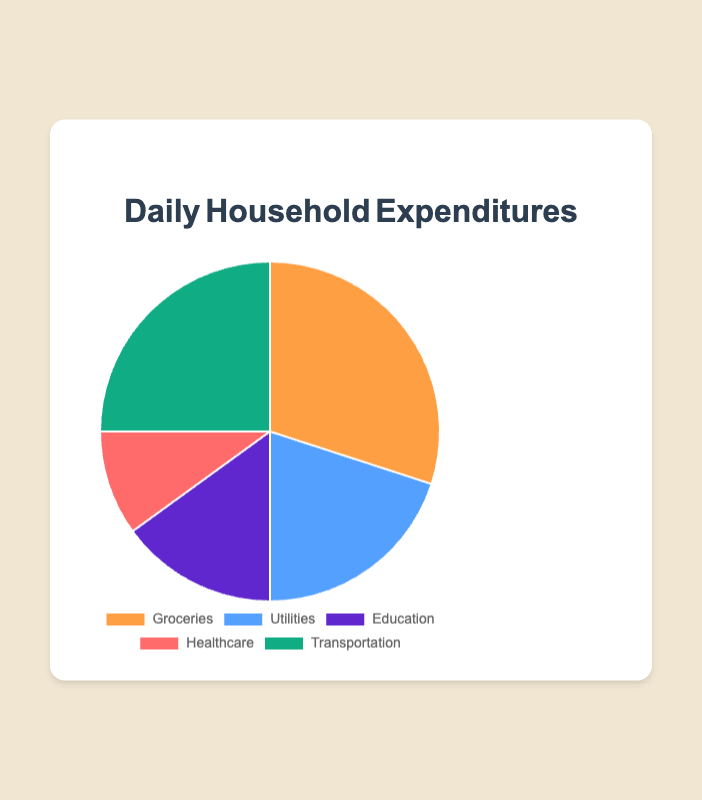What percentage of the total expenditures is spent on Groceries? The figure shows that Groceries account for 30% of the daily household expenditures.
Answer: 30% Which category has the second highest expenditure? From the pie chart, we see that Transportation is the second highest expenditure at 25%.
Answer: Transportation How much more is spent on Groceries compared to Healthcare? Groceries are 30% and Healthcare is 10%. Subtract the Healthcare percentage from Groceries: 30% - 10% = 20%.
Answer: 20% Which two categories combined make up the largest portion of expenditures? Groceries and Transportation together make up 30% + 25% = 55% of the total expenditures, which is the largest portion compared to any other combination.
Answer: Groceries and Transportation If the total daily expenditure is $100, how much is spent on Education? Since 15% is spent on Education, if the total is $100, then the amount spent on Education is 15% of $100, which is $15.
Answer: $15 What percentage of expenditures is spent on categories other than Groceries and Transportation? Groceries are 30% and Transportation is 25%. The percentage for other categories is 100% - (30% + 25%) = 45%.
Answer: 45% Is more money spent on Utilities or Healthcare? The pie chart shows 20% is spent on Utilities and 10% on Healthcare. Thus, more money is spent on Utilities.
Answer: Utilities What is the average percentage spent on Utilities, Education, and Healthcare? The percentages are 20% for Utilities, 15% for Education, and 10% for Healthcare. The average is (20 + 15 + 10) / 3 = 15%.
Answer: 15% Which category has the smallest expenditure and what is its percentage? Healthcare has the smallest expenditure at 10%.
Answer: Healthcare, 10% If the expenditure on Transportation doubled, what would its new percentage and the combined expenditure with Groceries be? Doubling the Transportation expenditure makes it 25% * 2 = 50%. Combined with Groceries, it would be 30% + 50% = 80%.
Answer: 50%, 80% 